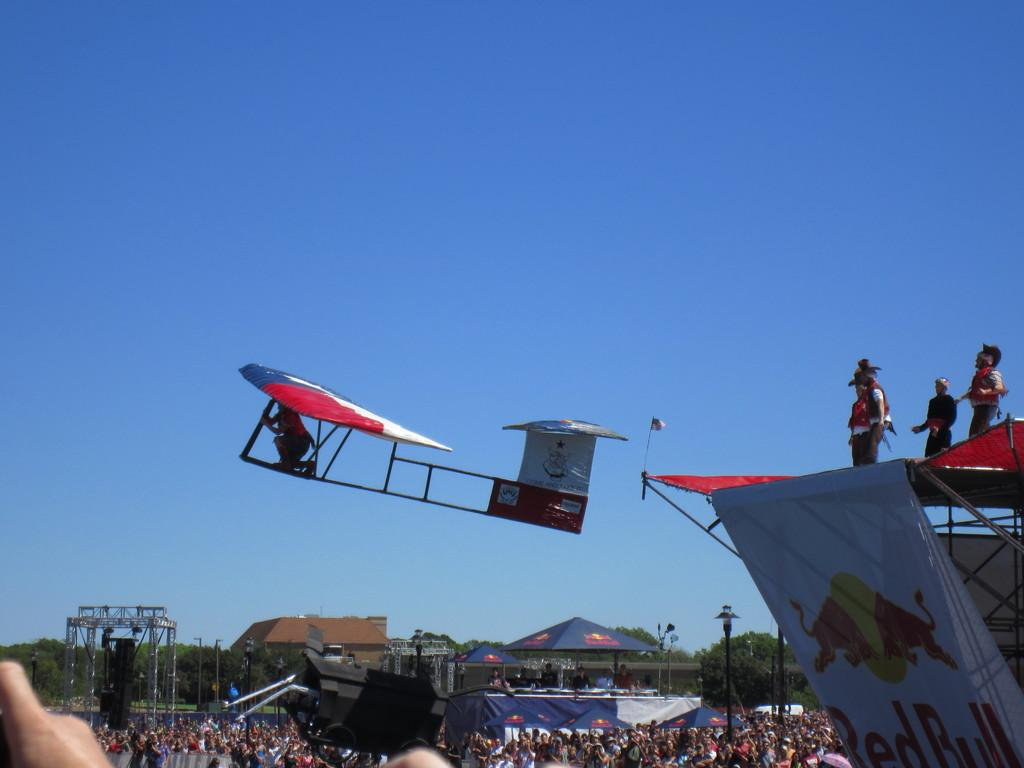<image>
Relay a brief, clear account of the picture shown. A few people standing above a banner advertising red bull 